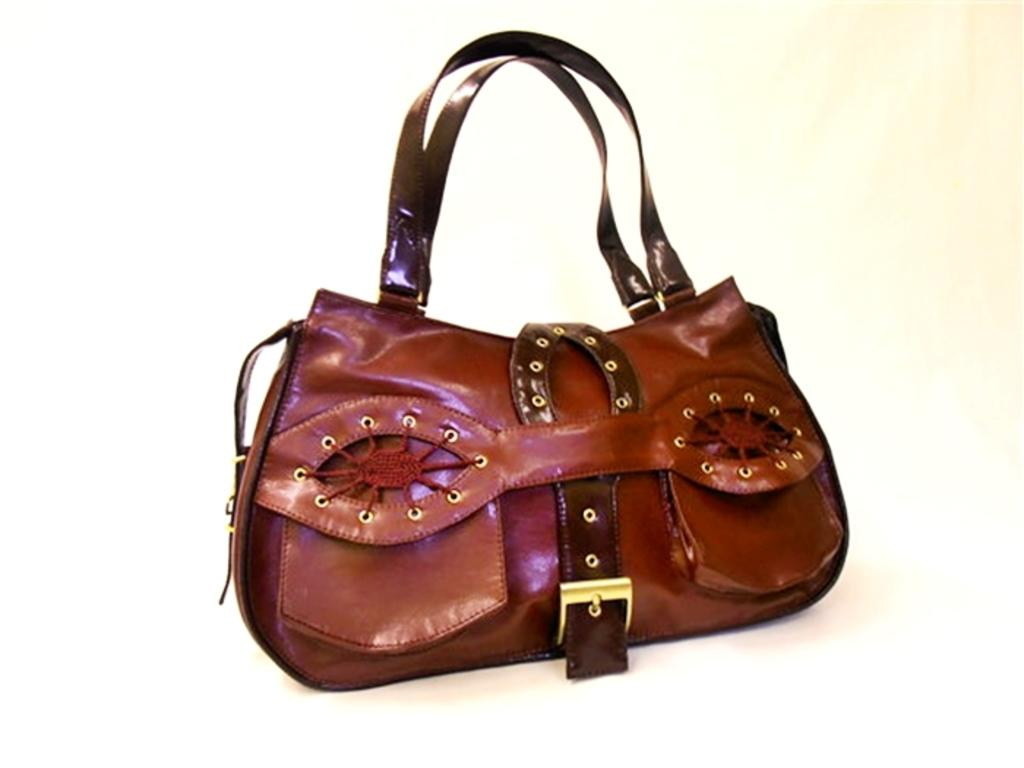What color is the bag in the image? The bag in the image is red. What feature of the bag allows it to be carried easily? The bag has handles, which allow it to be carried easily. What additional feature is present on the bag? The bag has a belt. What type of theory can be seen being applied to the pail in the image? There is no pail present in the image, and therefore no theory can be applied to it. 